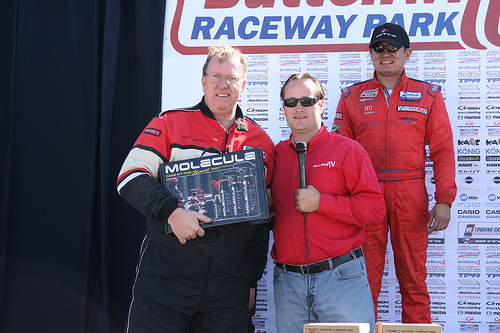<image>
Is there a shirt on the man? No. The shirt is not positioned on the man. They may be near each other, but the shirt is not supported by or resting on top of the man. 